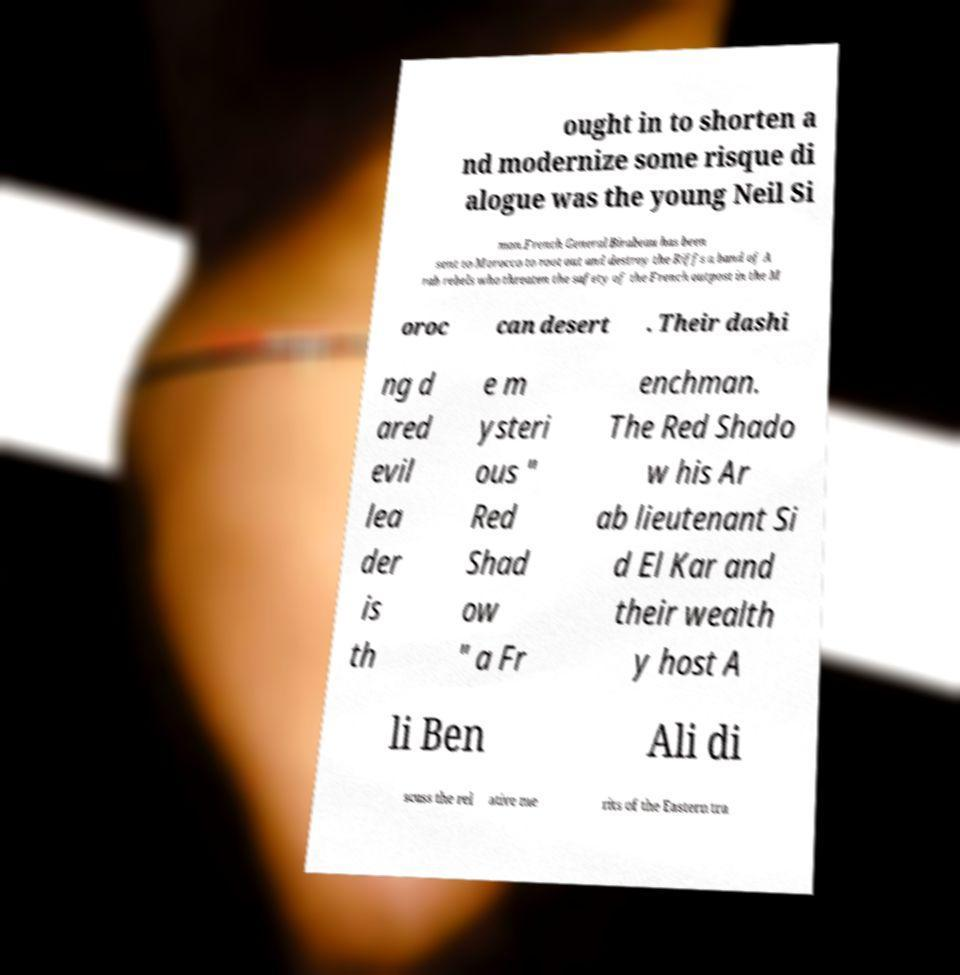Can you read and provide the text displayed in the image?This photo seems to have some interesting text. Can you extract and type it out for me? ought in to shorten a nd modernize some risque di alogue was the young Neil Si mon.French General Birabeau has been sent to Morocco to root out and destroy the Riffs a band of A rab rebels who threaten the safety of the French outpost in the M oroc can desert . Their dashi ng d ared evil lea der is th e m ysteri ous " Red Shad ow " a Fr enchman. The Red Shado w his Ar ab lieutenant Si d El Kar and their wealth y host A li Ben Ali di scuss the rel ative me rits of the Eastern tra 